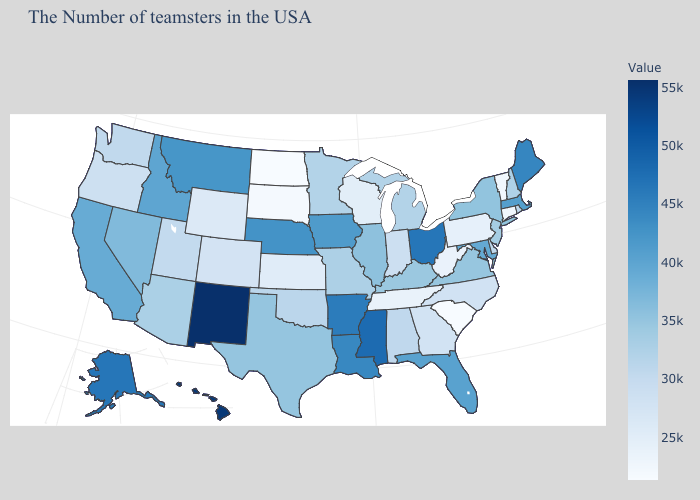Which states hav the highest value in the West?
Write a very short answer. New Mexico. Which states have the lowest value in the USA?
Write a very short answer. South Carolina, North Dakota. Among the states that border Arizona , does Colorado have the lowest value?
Be succinct. Yes. Among the states that border Massachusetts , does New York have the lowest value?
Answer briefly. No. 